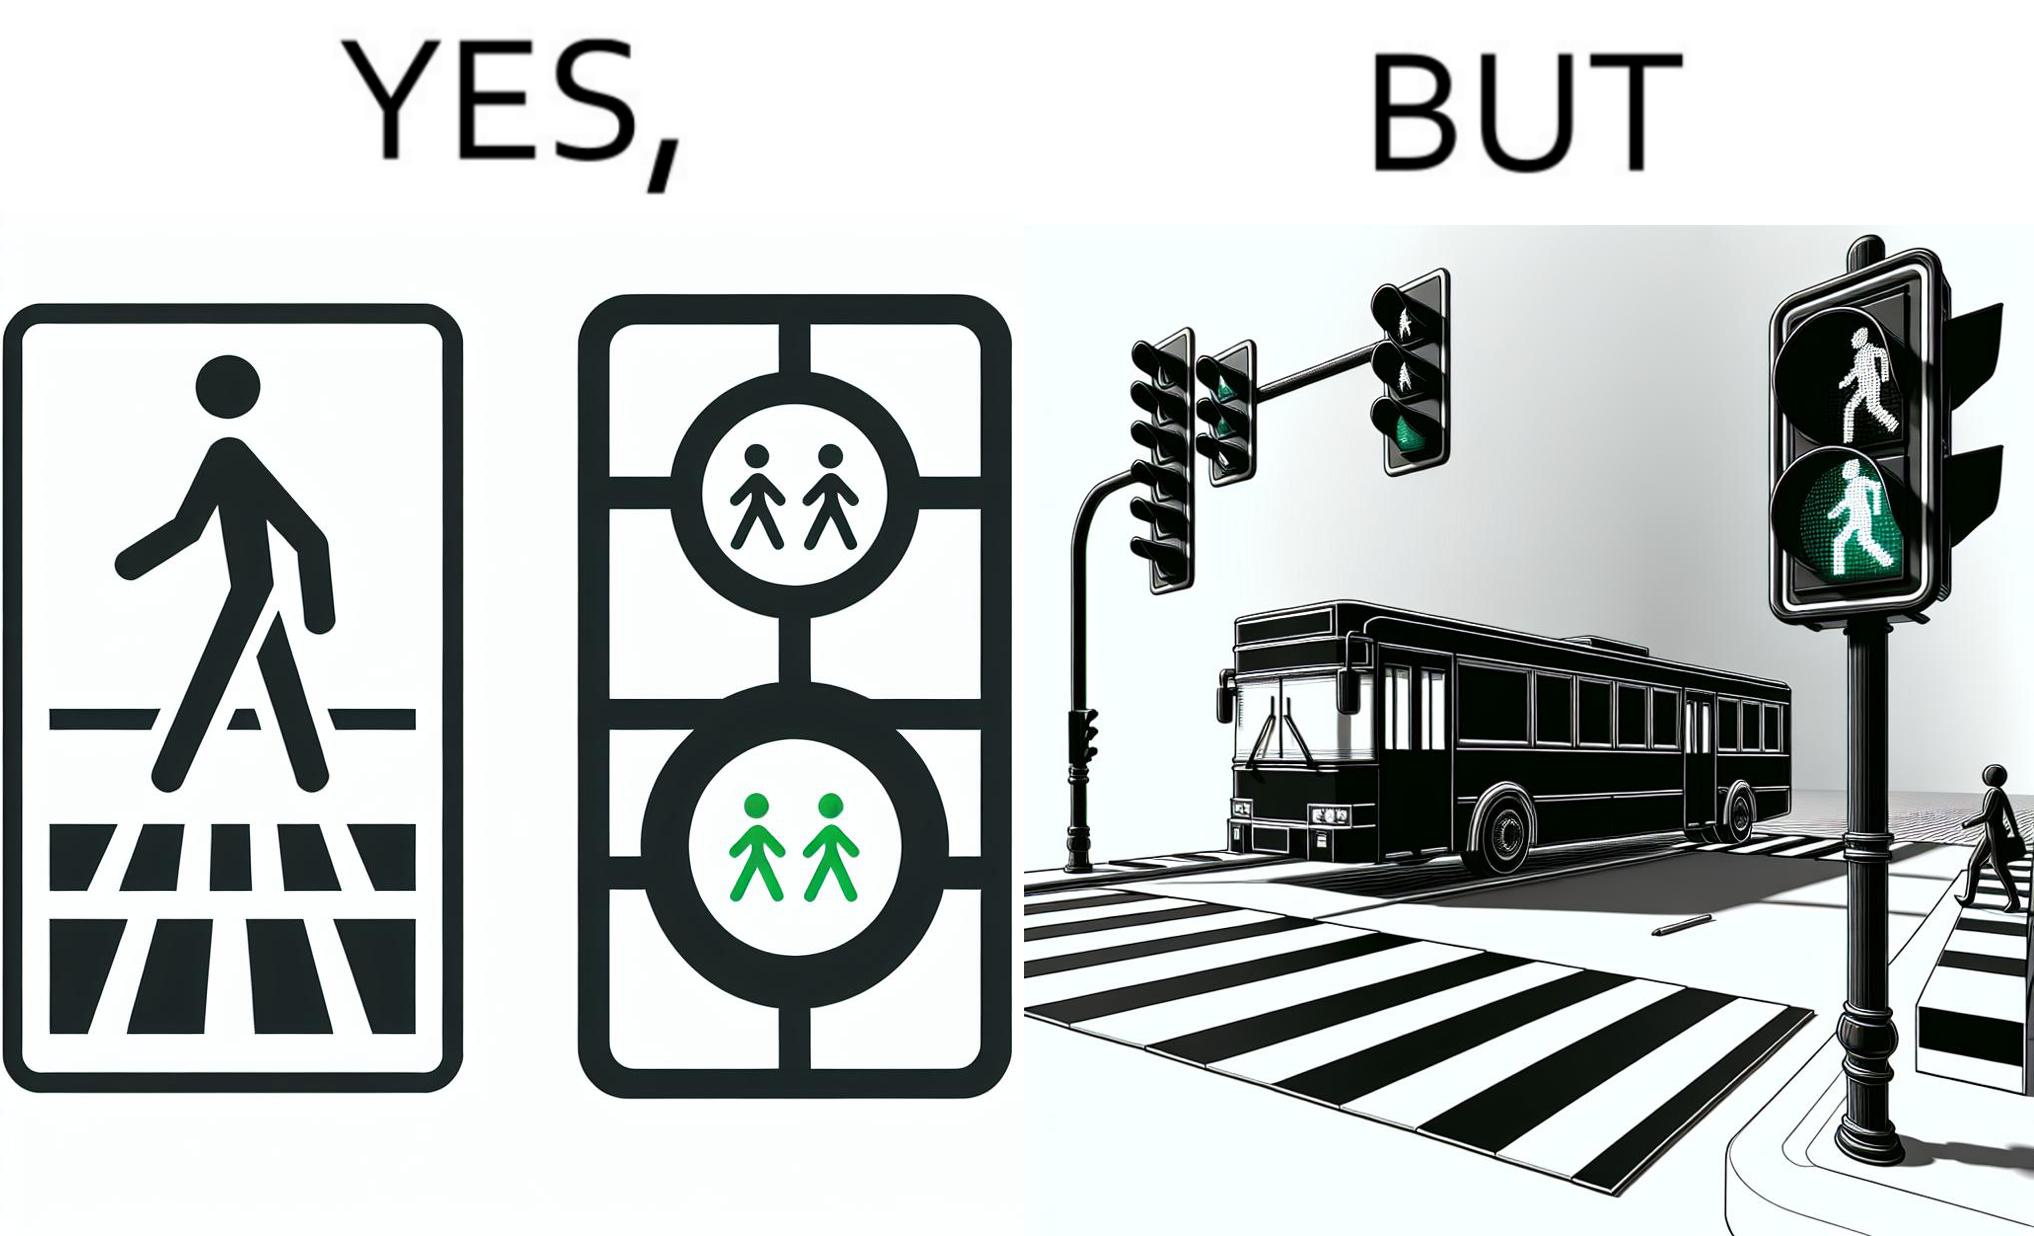Would you classify this image as satirical? Yes, this image is satirical. 